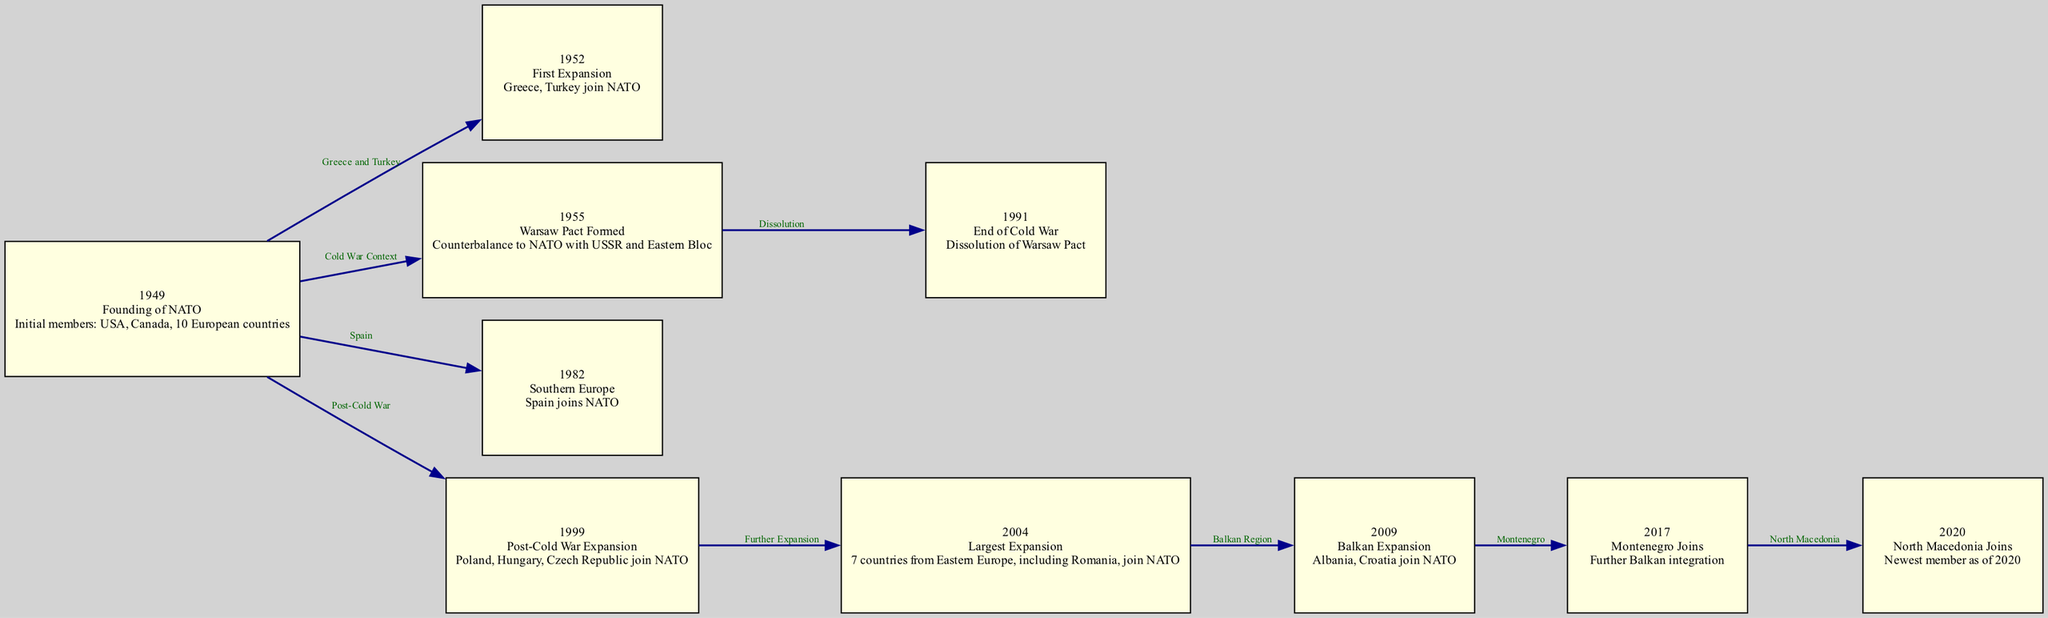What year was NATO founded? The diagram shows the node labeled "1949" which describes the founding of NATO. This node explicitly states the year of the founding event.
Answer: 1949 How many countries joined NATO in the first expansion? The node labeled "1952" indicates that Greece and Turkey joined NATO during the first expansion. Counting these countries gives a total of two.
Answer: 2 What event led to the dissolution of the Warsaw Pact? The edge connects the nodes for "Warsaw Pact Formed" (1955) and "End of Cold War" (1991). The label "Dissolution" on the edge indicates that this event corresponds to the dissolution context mentioned.
Answer: End of Cold War Which country joined NATO in 1982? The node labeled "1982" specifically states that Spain joined NATO in that year, providing a clear direct answer.
Answer: Spain How many countries joined NATO in 2004? The node labeled "2004" states that "7 countries from Eastern Europe" joined NATO during this largest expansion, which can be quantified directly.
Answer: 7 What was a consequence of the end of the Cold War regarding NATO? The diagram shows a relationship between the "End of Cold War" node and the "Post-Cold War Expansion" node (1999). It indicates that the dissolution of the Warsaw Pact allowed further NATO growth.
Answer: Post-Cold War Expansion Which two countries are connected in the relationship that describes the Balkan expansion? The edge connecting nodes for "2004" and "2009" indicates the countries involved in this context. The label "Balkan Region" also reflects that both nodes are part of this geographical expansion.
Answer: Albania and Croatia Who was the most recent member to join NATO as of 2020? The node labeled "2020" specifies North Macedonia as the newest member of NATO, clearly indicating this information.
Answer: North Macedonia 